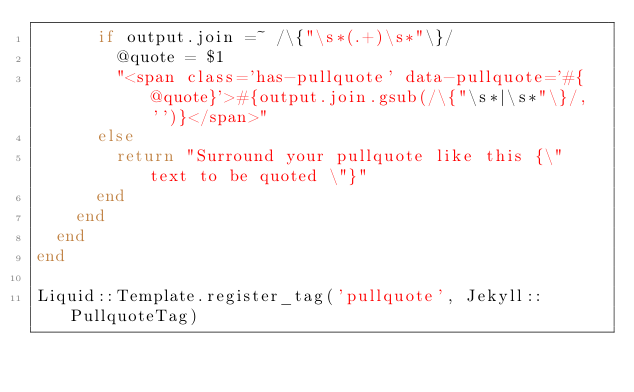Convert code to text. <code><loc_0><loc_0><loc_500><loc_500><_Ruby_>      if output.join =~ /\{"\s*(.+)\s*"\}/
        @quote = $1
        "<span class='has-pullquote' data-pullquote='#{@quote}'>#{output.join.gsub(/\{"\s*|\s*"\}/, '')}</span>"
      else
        return "Surround your pullquote like this {\" text to be quoted \"}"
      end
    end
  end
end

Liquid::Template.register_tag('pullquote', Jekyll::PullquoteTag)
</code> 